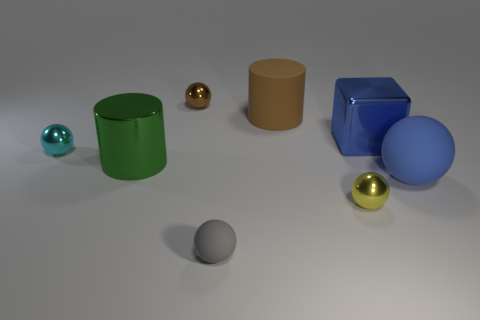How would you interpret the arrangement of the objects in this image? The objects in this image are arranged with no apparent pattern, suggesting randomness or an informal setting. It could be an artistic composition or simply a random arrangement for display. The varying colors, materials, and shapes offer a feast for the eyes, inviting viewers to contemplate the relationship between the objects. 